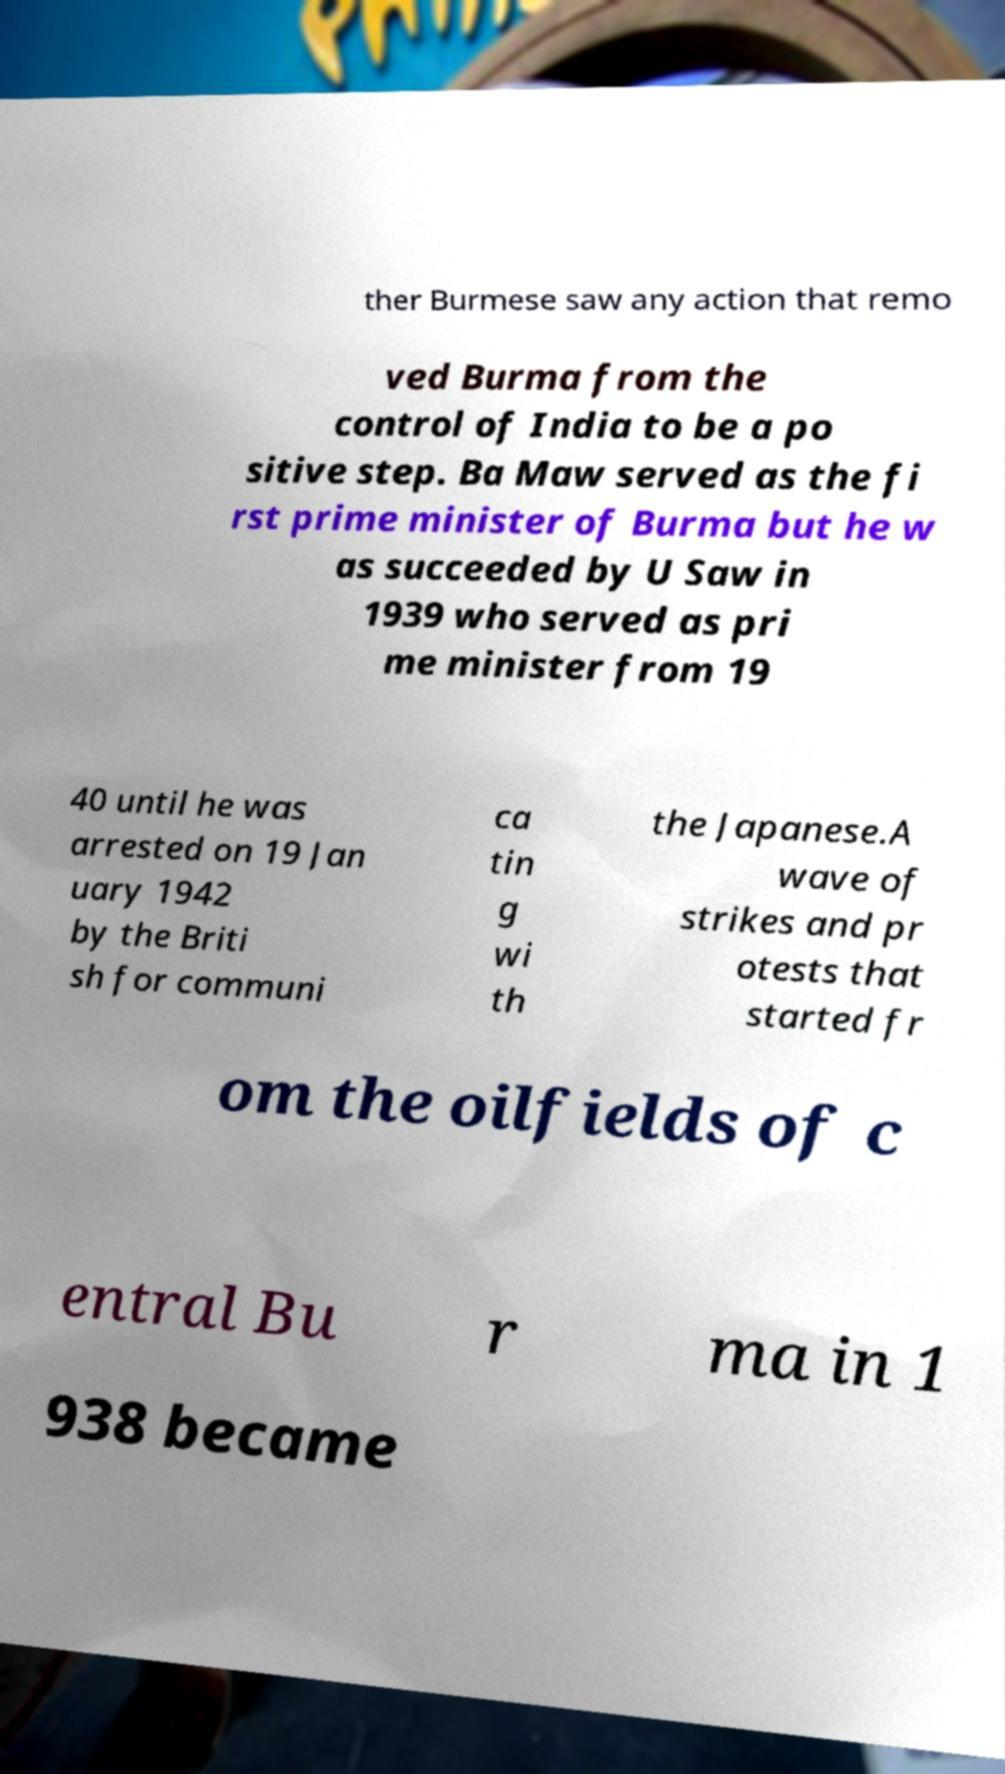Can you read and provide the text displayed in the image?This photo seems to have some interesting text. Can you extract and type it out for me? ther Burmese saw any action that remo ved Burma from the control of India to be a po sitive step. Ba Maw served as the fi rst prime minister of Burma but he w as succeeded by U Saw in 1939 who served as pri me minister from 19 40 until he was arrested on 19 Jan uary 1942 by the Briti sh for communi ca tin g wi th the Japanese.A wave of strikes and pr otests that started fr om the oilfields of c entral Bu r ma in 1 938 became 